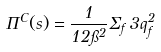<formula> <loc_0><loc_0><loc_500><loc_500>\Pi ^ { C } ( s ) = \frac { 1 } { 1 2 \pi ^ { 2 } } \Sigma _ { f } \, 3 q ^ { 2 } _ { f }</formula> 